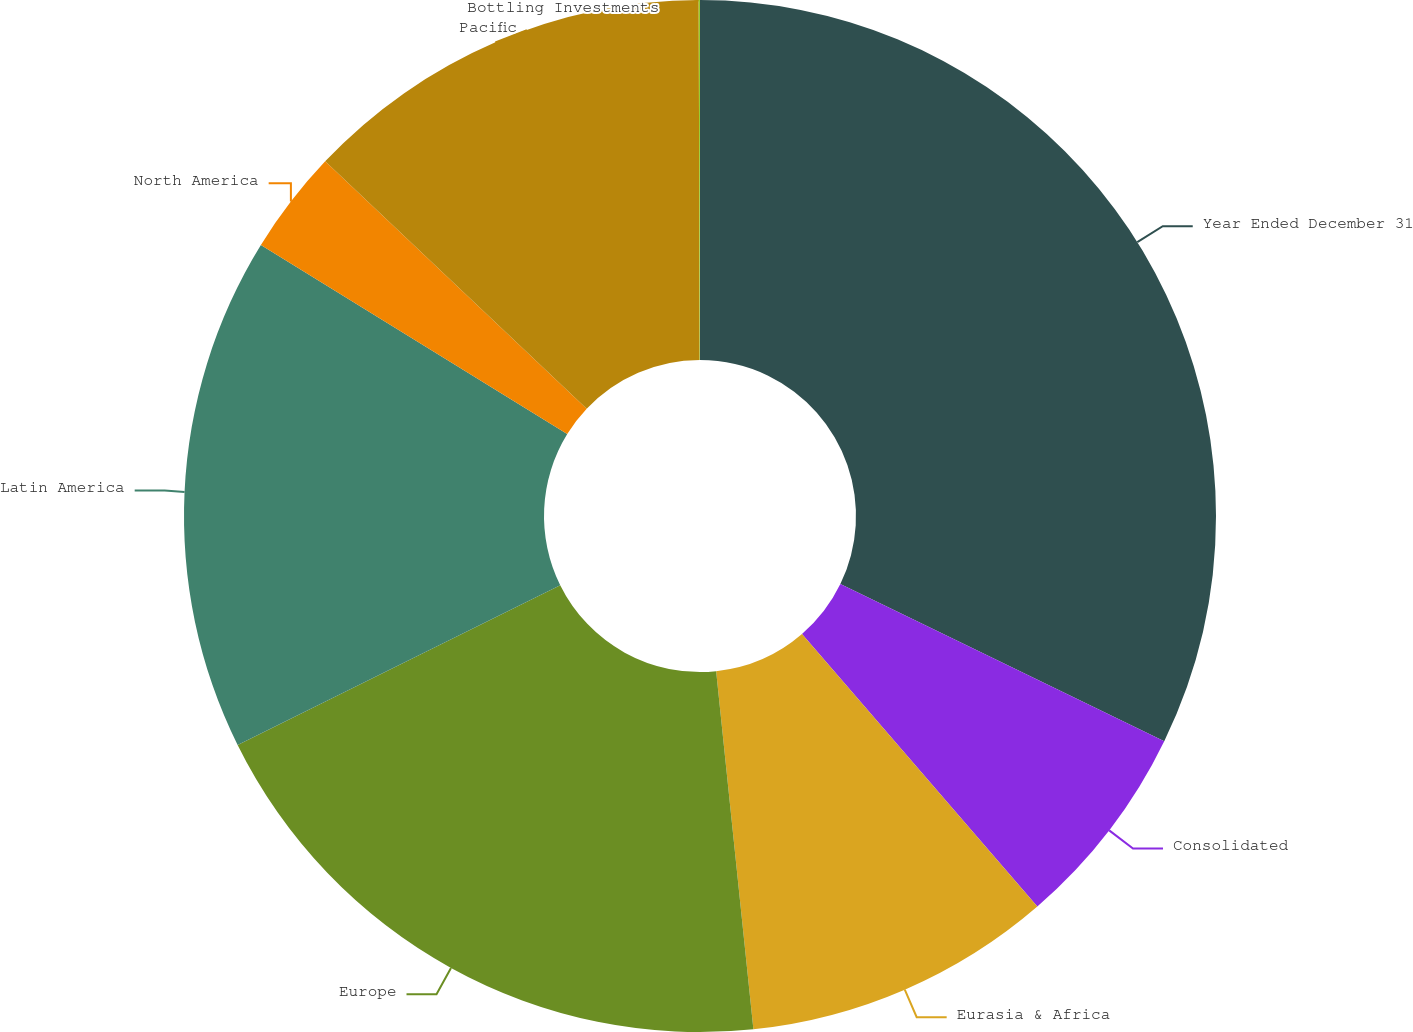<chart> <loc_0><loc_0><loc_500><loc_500><pie_chart><fcel>Year Ended December 31<fcel>Consolidated<fcel>Eurasia & Africa<fcel>Europe<fcel>Latin America<fcel>North America<fcel>Pacific<fcel>Bottling Investments<nl><fcel>32.19%<fcel>6.47%<fcel>9.69%<fcel>19.33%<fcel>16.12%<fcel>3.26%<fcel>12.9%<fcel>0.04%<nl></chart> 